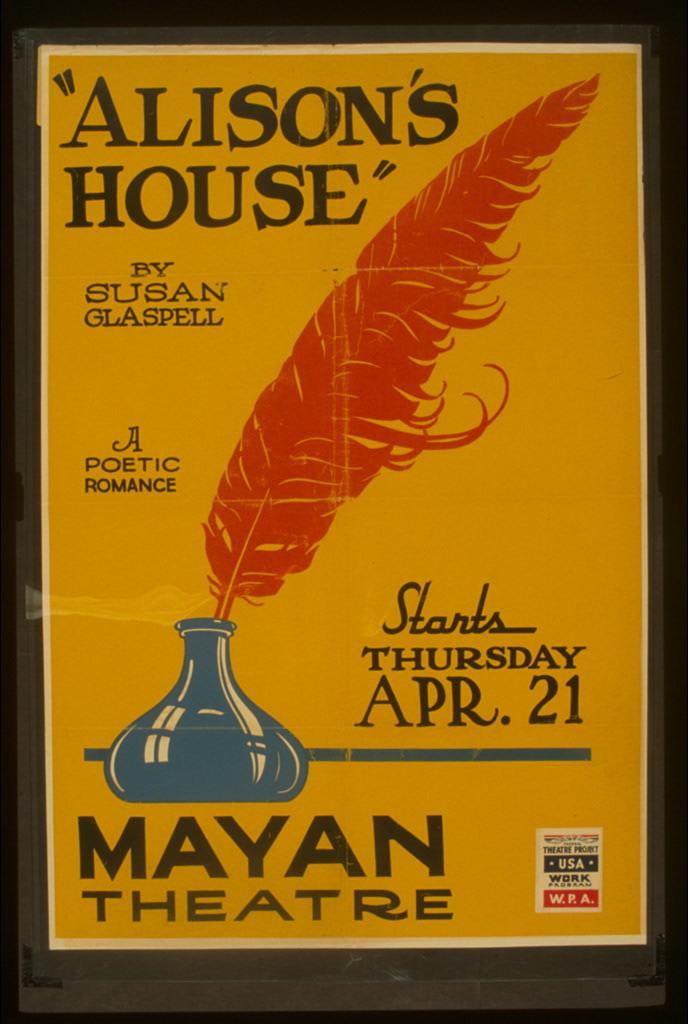Where is the play taking place?
Give a very brief answer. Mayan theatre. 